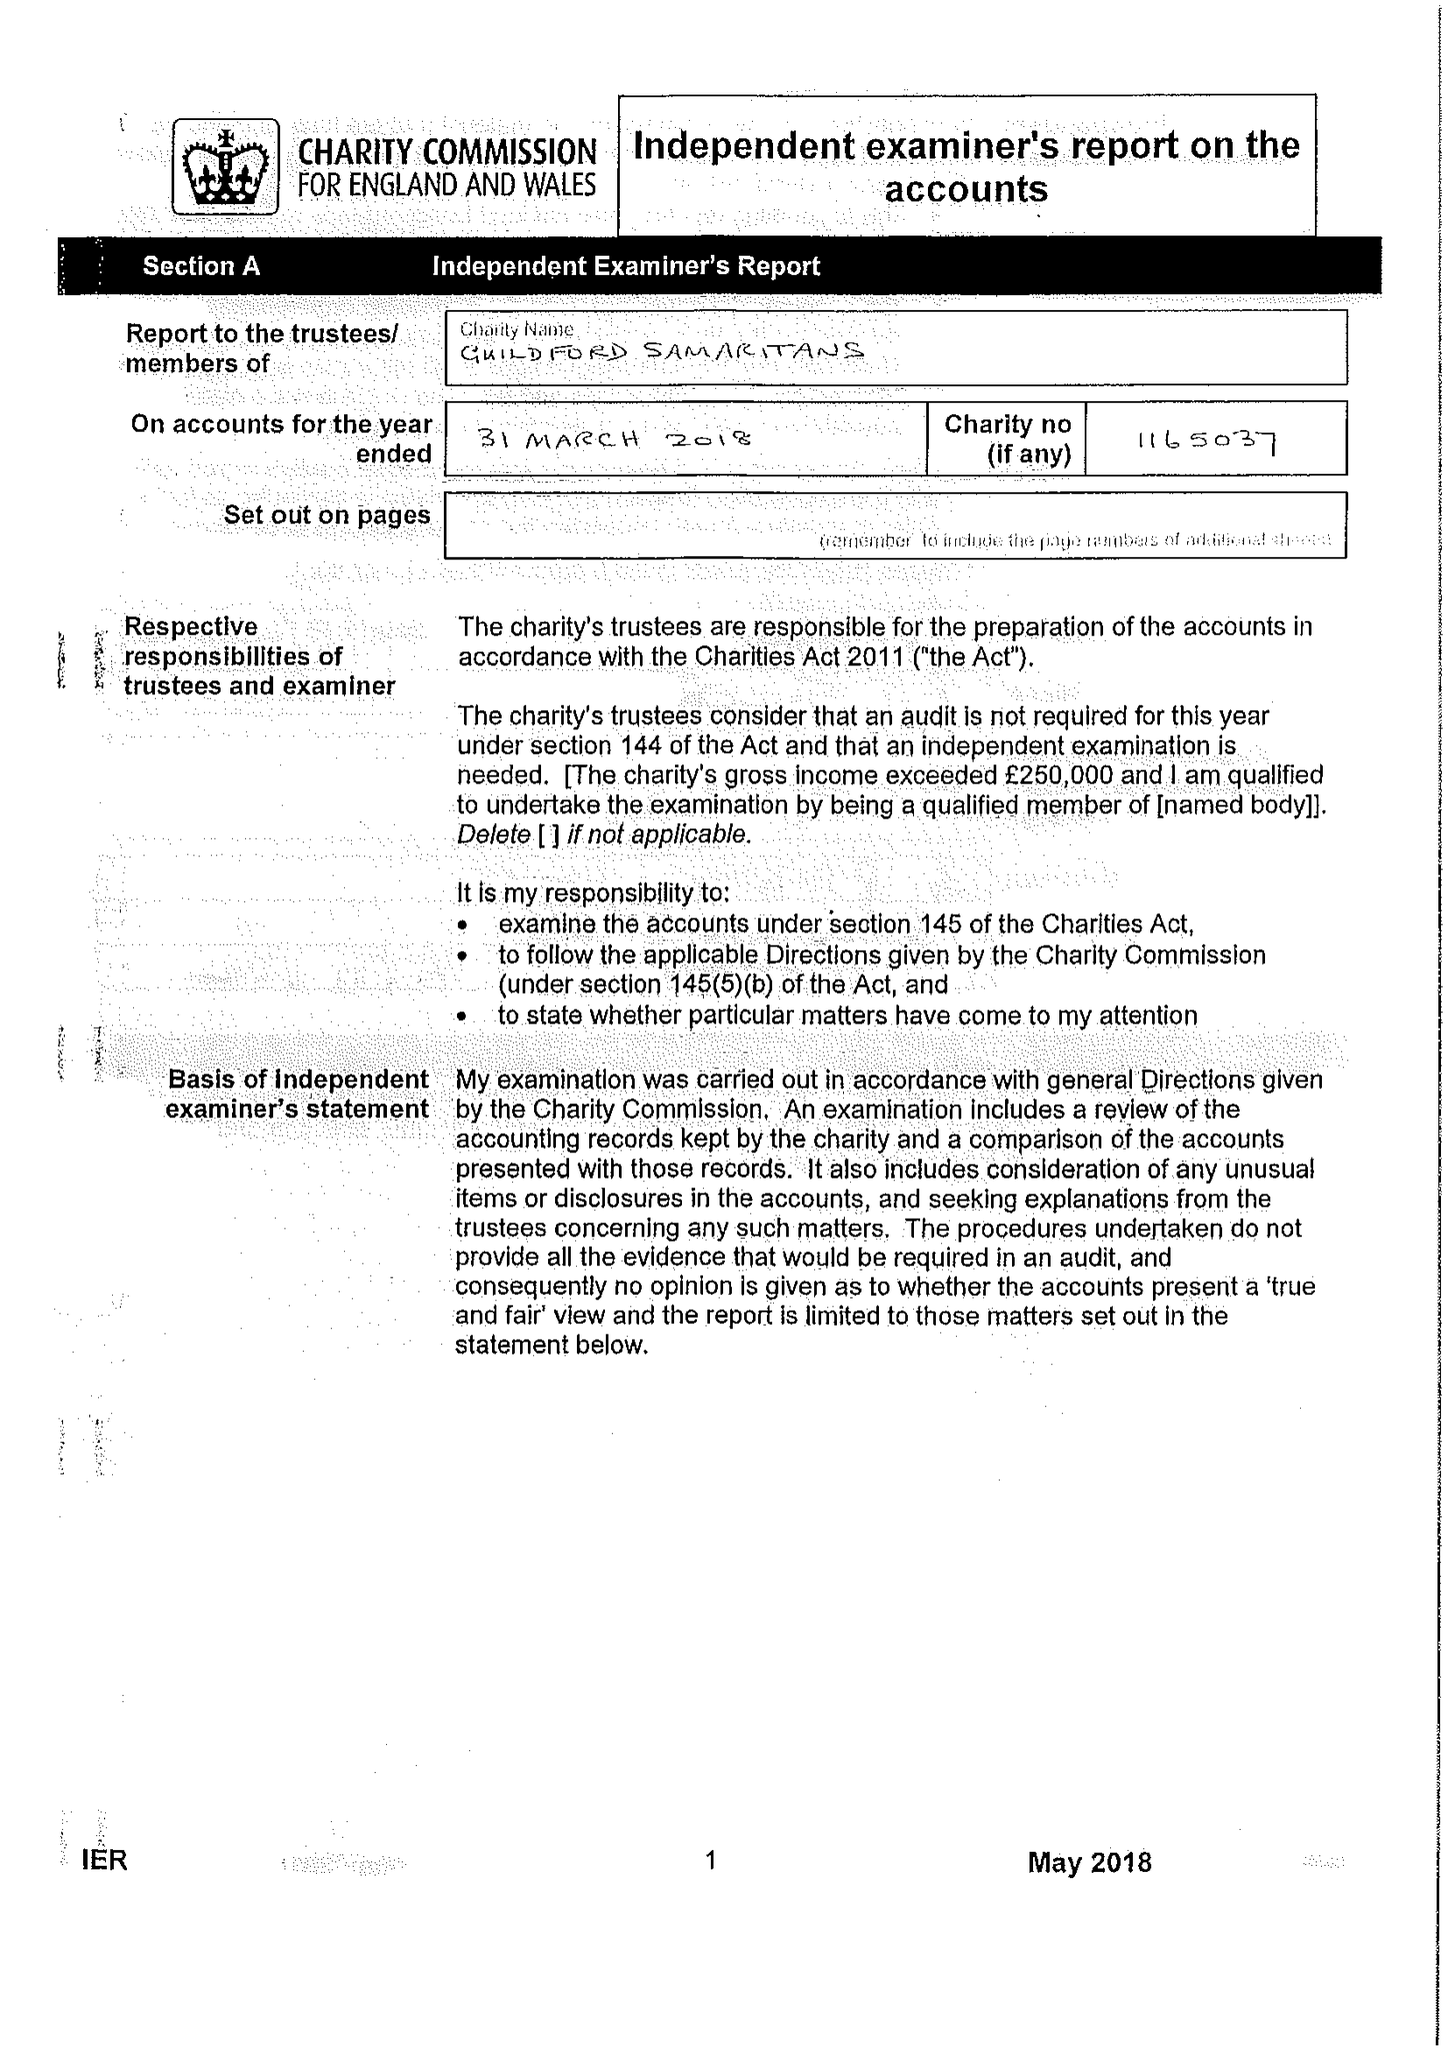What is the value for the address__post_town?
Answer the question using a single word or phrase. GUILDFORD 